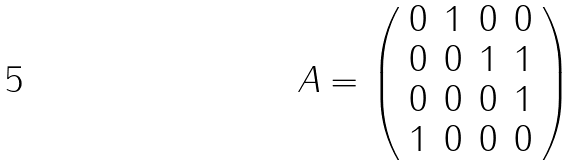Convert formula to latex. <formula><loc_0><loc_0><loc_500><loc_500>A = \left ( \begin{array} { c c c c } 0 & 1 & 0 & 0 \\ 0 & 0 & 1 & 1 \\ 0 & 0 & 0 & 1 \\ 1 & 0 & 0 & 0 \end{array} \right )</formula> 